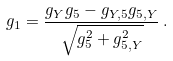Convert formula to latex. <formula><loc_0><loc_0><loc_500><loc_500>g _ { 1 } = \frac { g _ { Y } g _ { 5 } - g _ { Y , 5 } g _ { 5 , Y } } { \sqrt { g _ { 5 } ^ { 2 } + g _ { 5 , Y } ^ { 2 } } } \, .</formula> 